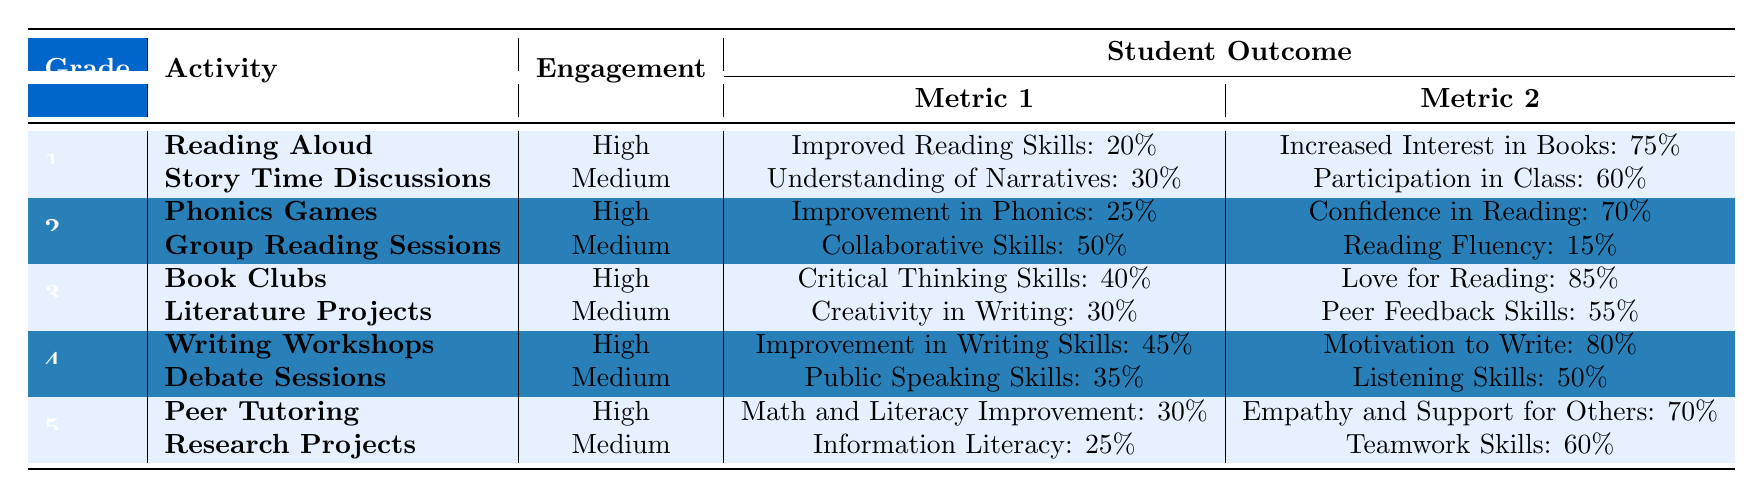What is the engagement level of the "Reading Aloud" activity in Grade 1? The table states that the engagement level for "Reading Aloud" in Grade 1 is "High."
Answer: High Which Grade activity shows the highest increase in "Increased Interest in Books"? The "Reading Aloud" activity in Grade 1 shows an increase of 75% in "Increased Interest in Books," which is the highest in the table.
Answer: Grade 1, Reading Aloud What percentage improvement is seen in "Critical Thinking Skills" through the "Book Clubs" activity in Grade 3? The table indicates that "Book Clubs" in Grade 3 leads to a 40% improvement in "Critical Thinking Skills."
Answer: 40% Is the "Improvement in Writing Skills" higher than "Improvement in Phonics" when comparing Grade 4 and Grade 2 activities? "Improvement in Writing Skills" from Grade 4 (45%) is higher than "Improvement in Phonics" from Grade 2 (25%).
Answer: Yes Calculate the average percentage of "Love for Reading" and "Increased Interest in Books." The percentage for "Love for Reading" is 85% (Grade 3) and "Increased Interest in Books" is 75% (Grade 1). Adding them gives 85% + 75% = 160%, and dividing by 2 yields an average of 80%.
Answer: 80% Which activity in Grade 5 has the lowest engagement level? In Grade 5, "Research Projects" has a medium engagement level; thus, it is the one with the lowest engagement compared to "Peer Tutoring," which is high.
Answer: Research Projects If the average improvement in reading skills for Grades 1 and 2 is calculated, what is the result? "Improvement in Reading Skills" is 20% for Grade 1 and "Improvement in Phonics" is 25% for Grade 2. Summing yields 20% + 25% = 45%, then average is 45% / 2 = 22.5%.
Answer: 22.5% Which Grade has the highest engagement level in the activities listed? Examining the highest engagement levels across the grades, Grade 1, Grade 2, Grade 3, Grade 4, and Grade 5 all have at least one activity rated as "High." Therefore, each grade has high engagement activities.
Answer: All Grades have high engagement activities 